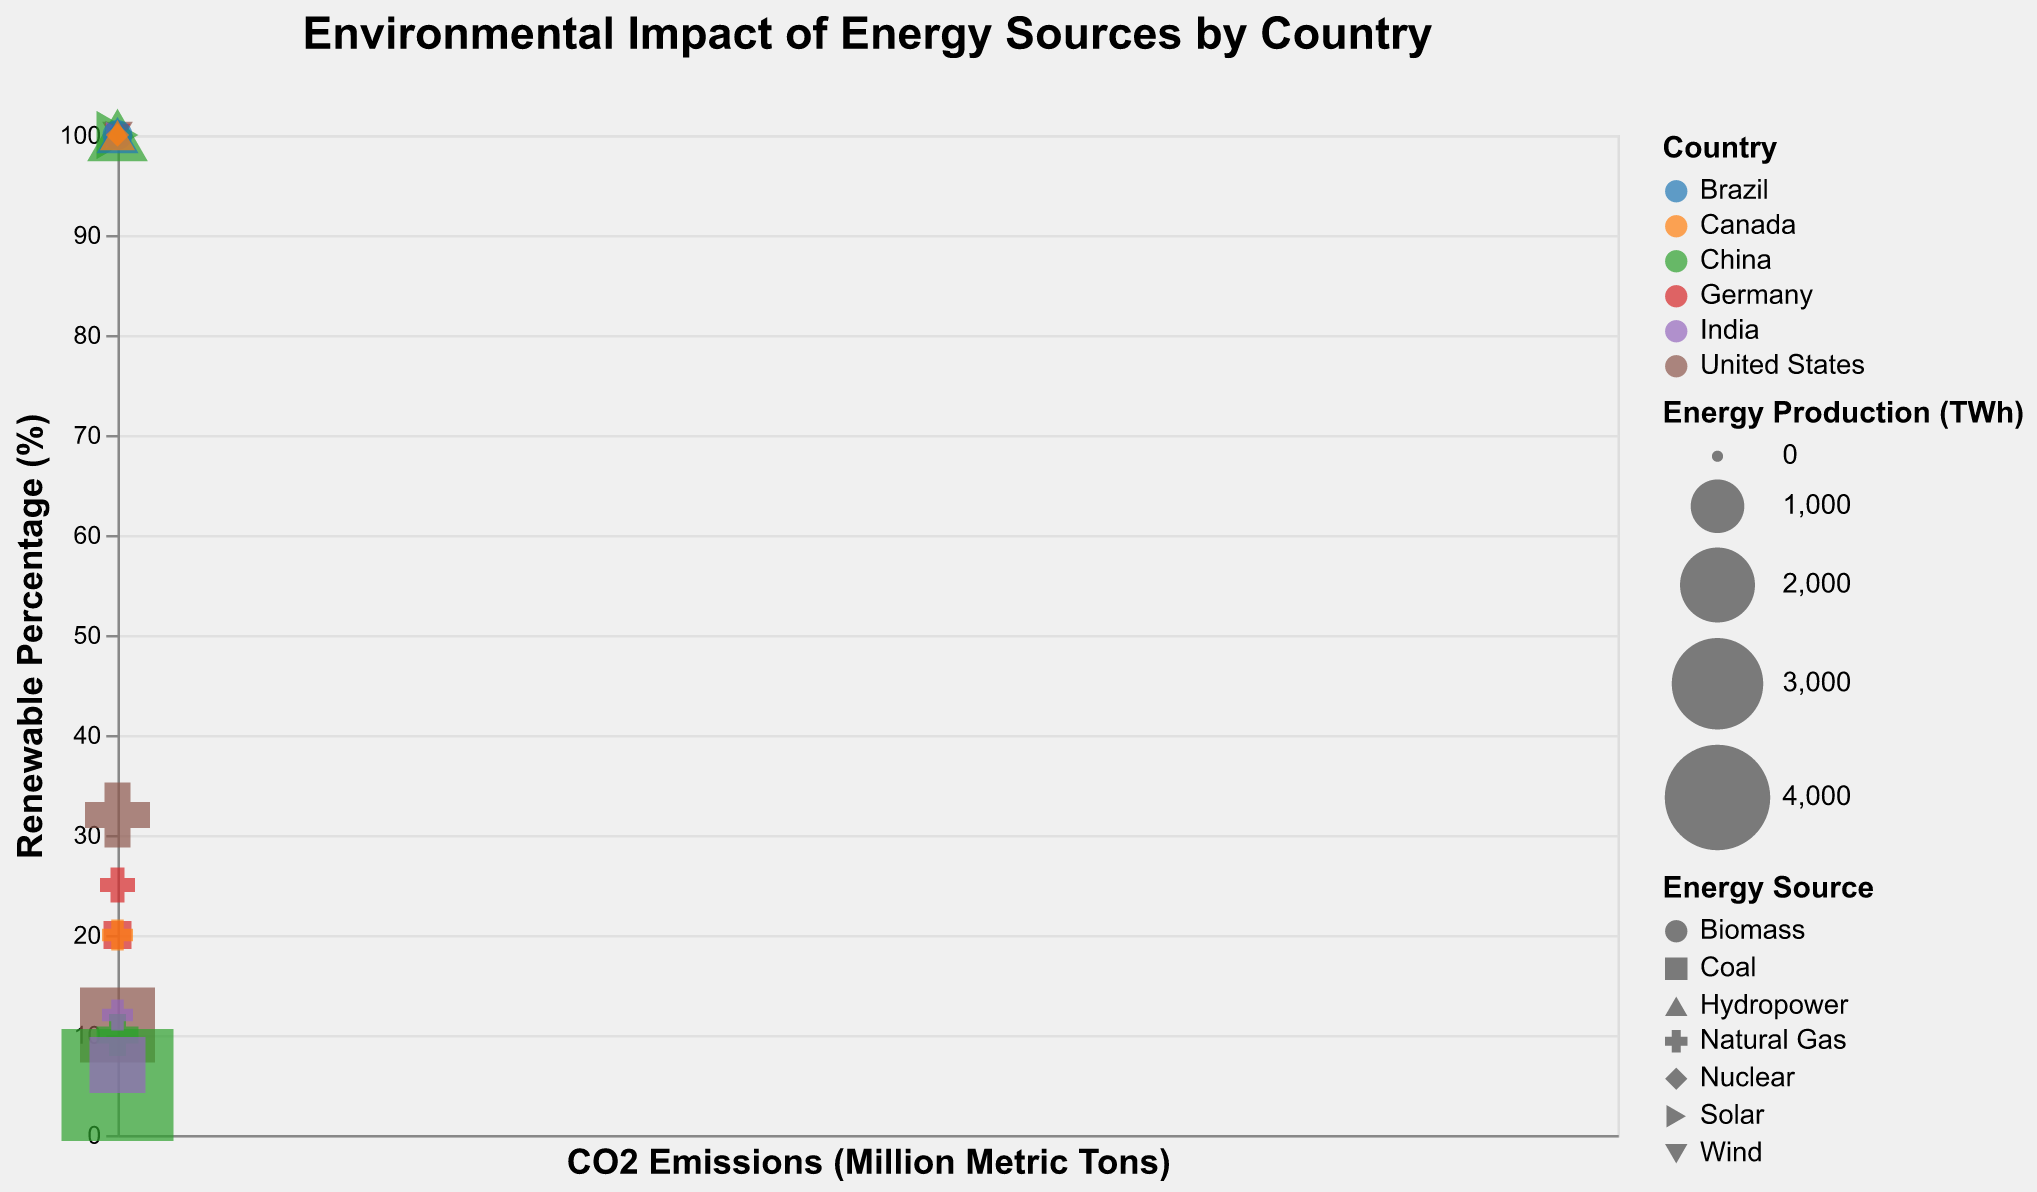What is the title of the figure? The title of the figure is positioned at the top center of the chart and is larger and bolder compared to other text elements.
Answer: Environmental Impact of Energy Sources by Country Which country has the highest CO2 emissions from its coal energy source? The CO2 emissions are represented on the x-axis, and the countries can be differentiated by color. The data point with the highest x-axis value (CO2 Emissions) among "Coal" is labeled as "China."
Answer: China Which energy source in Germany has the highest renewable percentage? By looking at the y-axis (Renewable Percentage), we can observe the points associated with Germany. The points for renewable energy sources like Wind and Solar are at 100%, indicating the highest renewable percentage.
Answer: Wind and Solar What is the size of the bubble representing solar energy in China? The bubble size represents Energy Production measured in TWh. The tooltip for the solar energy bubble in China shows an Energy Production of 800 TWh.
Answer: 800 TWh Compare the CO2 emissions from coal energy sources between the United States and India. Which is higher? The CO2 Emissions on the x-axis can be compared by looking at the position of the coal energy points for both countries. The United States has 1300 Million Metric Tons whereas India has 2200 Million Metric Tons. Hence, India's emissions are higher.
Answer: India What is the relationship between renewable percentage and CO2 emissions for hydropower energy sources? Hydropower points are located at the 100% mark on the y-axis (Renewable Percentage). All hydropower points have 0 CO2 Emissions as indicated on the x-axis, suggesting a relationship where hydropower is fully renewable with zero CO2 emissions.
Answer: Hydropower is fully renewable with zero CO2 emissions Which country has the highest total energy production for all energy sources combined? To find the country with the highest total energy production, sum the Energy Production values for each energy source by country. By examining the chart, China appears to have the larger cumulative bubble sizes for its energy sources.
Answer: China Calculate the difference in renewable percentage between natural gas and wind energy in the United States. The renewable percentage for natural gas in the US is 32%, and for wind, it is 100%. The difference is given by 100% - 32%.
Answer: 68% Which energy source in Brazil has the smallest energy production? The bubble size for each energy source can be compared within Brazil. The smallest bubble among Brazil's energy sources represents Wind with an Energy Production of 50 TWh.
Answer: Wind What patterns can you observe about renewable energy sources across all countries? By categorizing the renewable energy sources (Wind, Solar, Hydropower, Biomass, Nuclear), we can observe that they consistently have a 100% renewable percentage. Additionally, they tend to have zero CO2 emissions. This pattern is evident from the respect positions in the chart.
Answer: Renewable energy sources consistently have 100% renewable percentage and zero CO2 emissions 